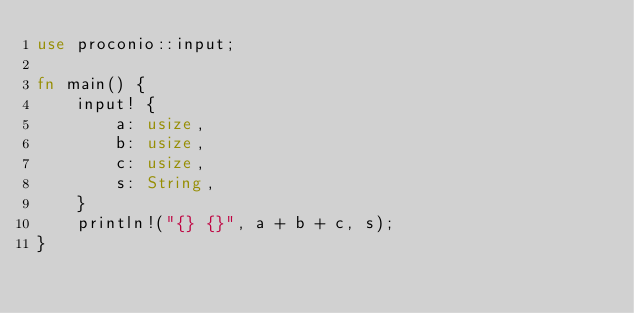<code> <loc_0><loc_0><loc_500><loc_500><_Rust_>use proconio::input;

fn main() {
    input! {
        a: usize,
        b: usize,
        c: usize,
        s: String,
    }
    println!("{} {}", a + b + c, s);
}
</code> 